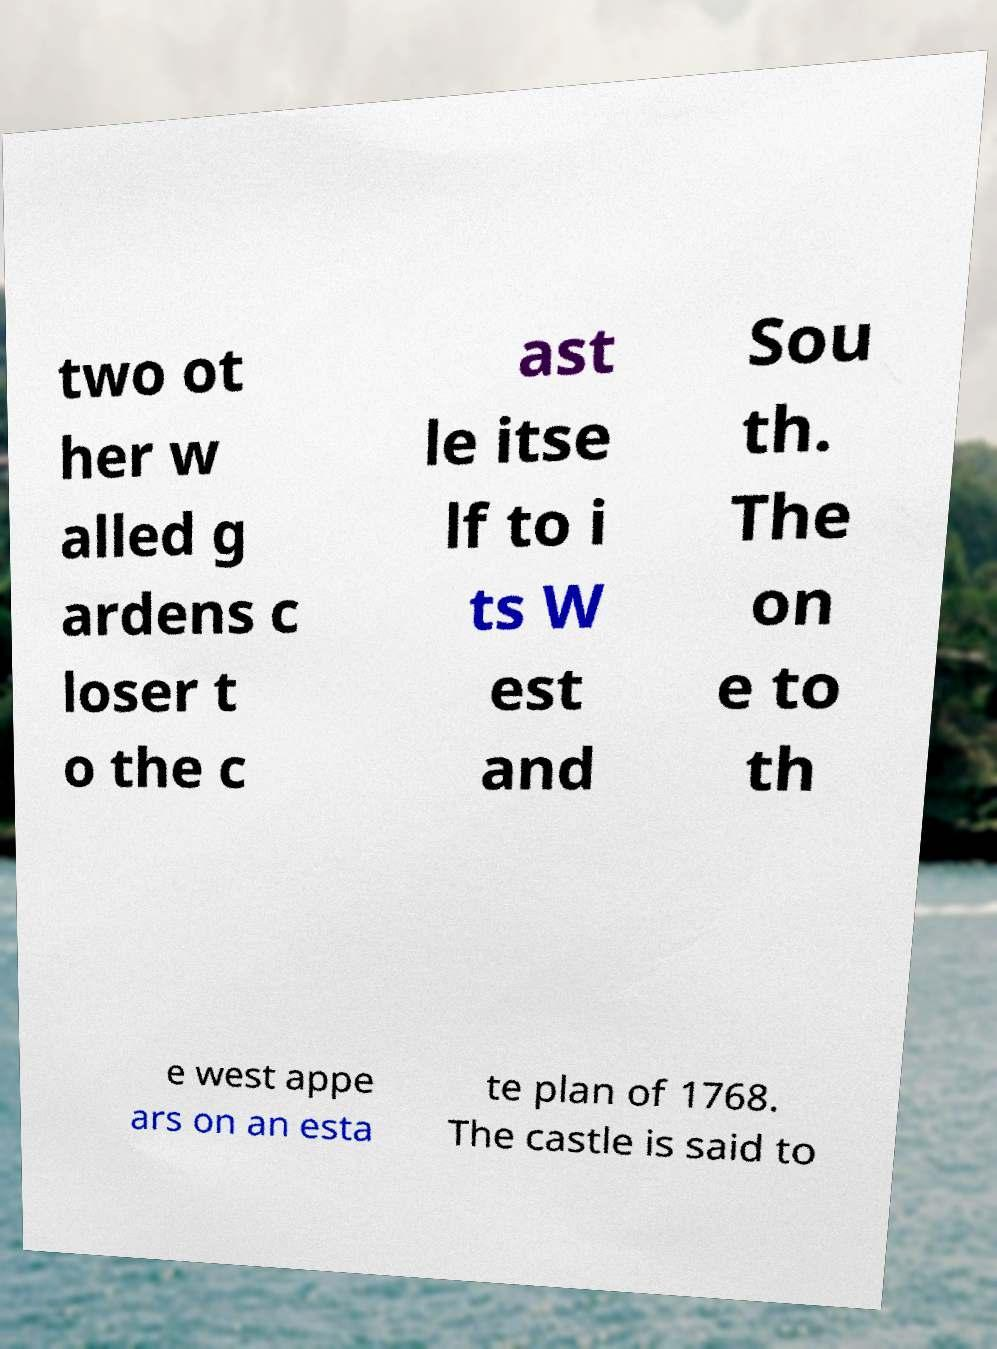Please identify and transcribe the text found in this image. two ot her w alled g ardens c loser t o the c ast le itse lf to i ts W est and Sou th. The on e to th e west appe ars on an esta te plan of 1768. The castle is said to 